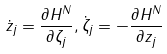<formula> <loc_0><loc_0><loc_500><loc_500>\dot { z } _ { j } = \frac { \partial H ^ { N } } { \partial \zeta _ { j } } , \dot { \zeta } _ { j } = - \frac { \partial H ^ { N } } { \partial z _ { j } }</formula> 